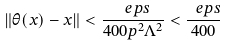<formula> <loc_0><loc_0><loc_500><loc_500>\| \theta ( x ) - x \| < \frac { \ e p s } { 4 0 0 p ^ { 2 } \Lambda ^ { 2 } } < \frac { \ e p s } { 4 0 0 }</formula> 